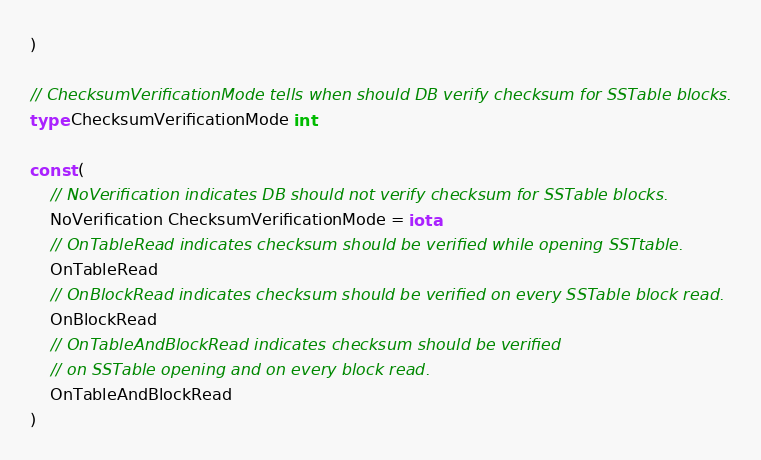<code> <loc_0><loc_0><loc_500><loc_500><_Go_>)

// ChecksumVerificationMode tells when should DB verify checksum for SSTable blocks.
type ChecksumVerificationMode int

const (
	// NoVerification indicates DB should not verify checksum for SSTable blocks.
	NoVerification ChecksumVerificationMode = iota
	// OnTableRead indicates checksum should be verified while opening SSTtable.
	OnTableRead
	// OnBlockRead indicates checksum should be verified on every SSTable block read.
	OnBlockRead
	// OnTableAndBlockRead indicates checksum should be verified
	// on SSTable opening and on every block read.
	OnTableAndBlockRead
)
</code> 